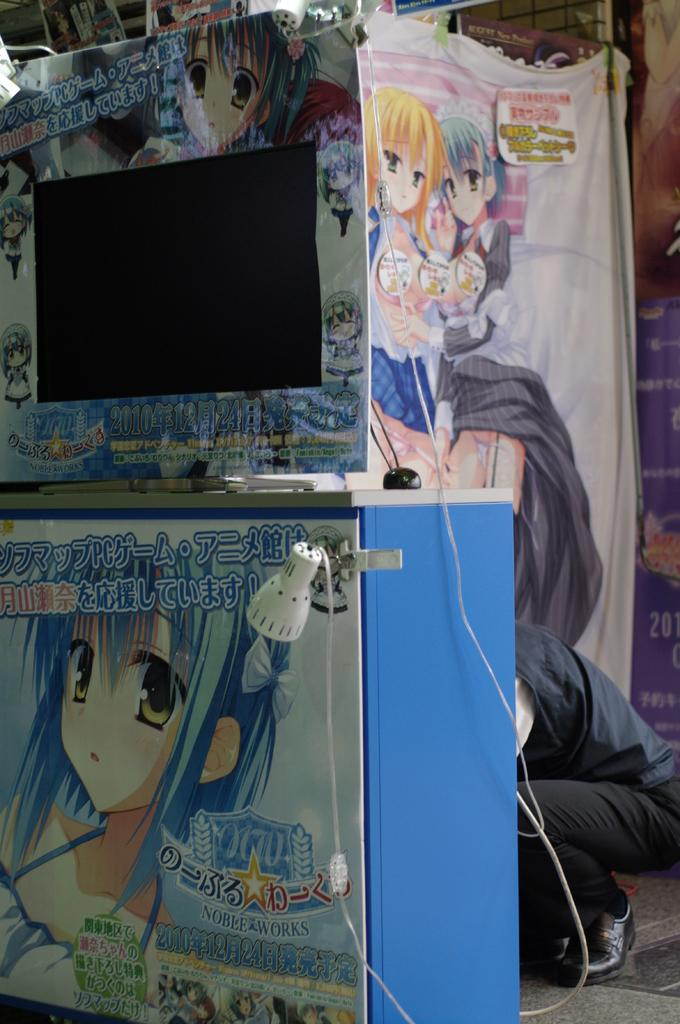What is hanging in the image? There is a banner in the image. What type of images are on the banner? The banner contains cartoon pictures. Can you describe the person visible in the image? Unfortunately, the provided facts do not give any information about the person in the image. What type of grass is growing near the banner in the image? There is no grass present in the image. How does the thunder sound in the image? There is no mention of thunder in the image, so it cannot be heard or described. 